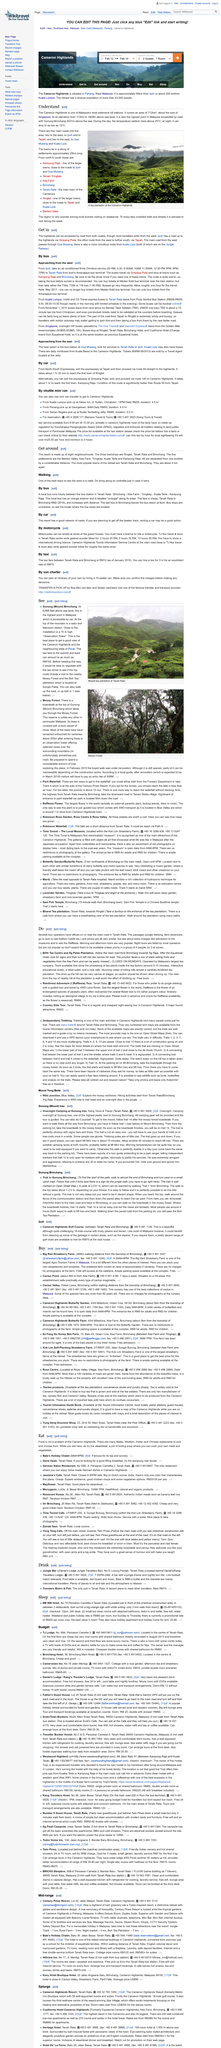Draw attention to some important aspects in this diagram. In order to rent a geared scooter, an international driver's license is required. The most commonly utilized route for accessing the highlands is through the western region, as stated by a vast majority of travelers. The taxi fare to reach the summit of Gunung Brinchang is RM100, according to the information provided. The tea plantation in the top photograph is called Bharat tea plantation. The cost of the bus from Tanah Rata to Brinchang is RM2. 